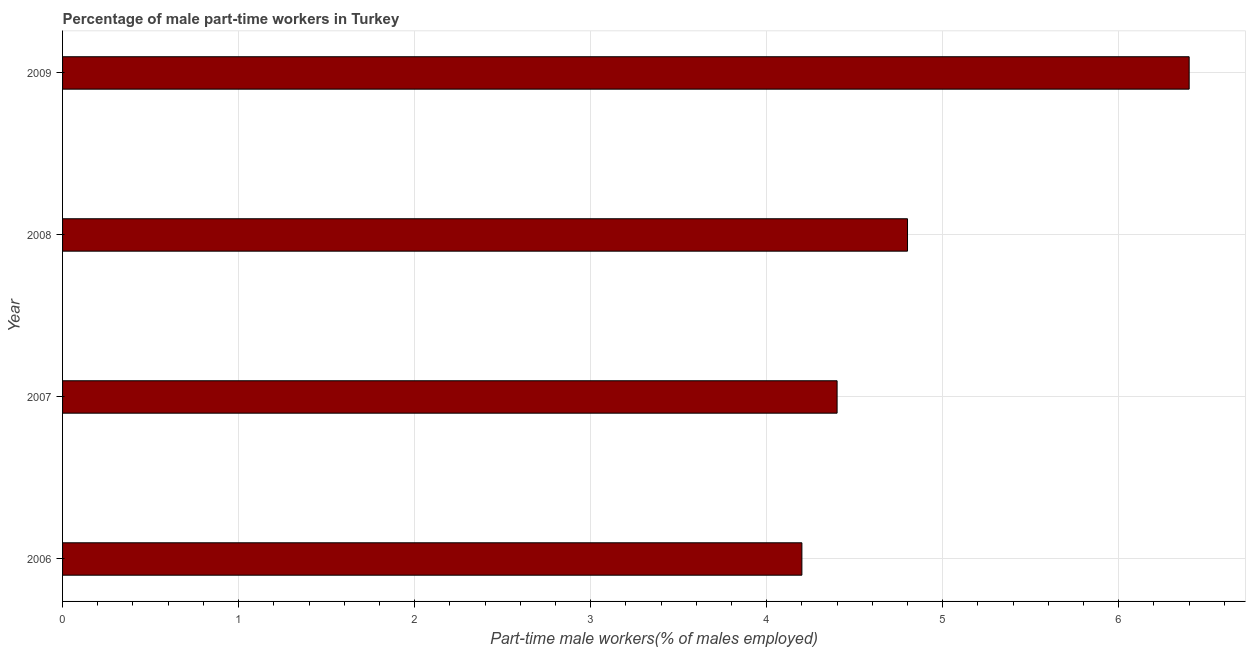Does the graph contain any zero values?
Your answer should be very brief. No. Does the graph contain grids?
Keep it short and to the point. Yes. What is the title of the graph?
Your answer should be compact. Percentage of male part-time workers in Turkey. What is the label or title of the X-axis?
Your response must be concise. Part-time male workers(% of males employed). What is the percentage of part-time male workers in 2009?
Offer a very short reply. 6.4. Across all years, what is the maximum percentage of part-time male workers?
Offer a terse response. 6.4. Across all years, what is the minimum percentage of part-time male workers?
Your answer should be very brief. 4.2. In which year was the percentage of part-time male workers maximum?
Keep it short and to the point. 2009. In which year was the percentage of part-time male workers minimum?
Your answer should be compact. 2006. What is the sum of the percentage of part-time male workers?
Provide a succinct answer. 19.8. What is the average percentage of part-time male workers per year?
Offer a terse response. 4.95. What is the median percentage of part-time male workers?
Offer a very short reply. 4.6. Do a majority of the years between 2008 and 2009 (inclusive) have percentage of part-time male workers greater than 4.8 %?
Give a very brief answer. Yes. What is the ratio of the percentage of part-time male workers in 2006 to that in 2007?
Your answer should be very brief. 0.95. Is the difference between the percentage of part-time male workers in 2006 and 2007 greater than the difference between any two years?
Keep it short and to the point. No. What is the difference between the highest and the second highest percentage of part-time male workers?
Your response must be concise. 1.6. Is the sum of the percentage of part-time male workers in 2006 and 2008 greater than the maximum percentage of part-time male workers across all years?
Ensure brevity in your answer.  Yes. What is the difference between the highest and the lowest percentage of part-time male workers?
Your answer should be very brief. 2.2. In how many years, is the percentage of part-time male workers greater than the average percentage of part-time male workers taken over all years?
Provide a succinct answer. 1. How many bars are there?
Provide a succinct answer. 4. Are all the bars in the graph horizontal?
Make the answer very short. Yes. How many years are there in the graph?
Provide a short and direct response. 4. What is the difference between two consecutive major ticks on the X-axis?
Make the answer very short. 1. What is the Part-time male workers(% of males employed) of 2006?
Your response must be concise. 4.2. What is the Part-time male workers(% of males employed) in 2007?
Your answer should be very brief. 4.4. What is the Part-time male workers(% of males employed) of 2008?
Ensure brevity in your answer.  4.8. What is the Part-time male workers(% of males employed) of 2009?
Offer a terse response. 6.4. What is the difference between the Part-time male workers(% of males employed) in 2006 and 2007?
Your answer should be very brief. -0.2. What is the difference between the Part-time male workers(% of males employed) in 2006 and 2009?
Ensure brevity in your answer.  -2.2. What is the difference between the Part-time male workers(% of males employed) in 2007 and 2008?
Offer a terse response. -0.4. What is the difference between the Part-time male workers(% of males employed) in 2007 and 2009?
Your answer should be very brief. -2. What is the ratio of the Part-time male workers(% of males employed) in 2006 to that in 2007?
Offer a very short reply. 0.95. What is the ratio of the Part-time male workers(% of males employed) in 2006 to that in 2008?
Ensure brevity in your answer.  0.88. What is the ratio of the Part-time male workers(% of males employed) in 2006 to that in 2009?
Your answer should be very brief. 0.66. What is the ratio of the Part-time male workers(% of males employed) in 2007 to that in 2008?
Offer a terse response. 0.92. What is the ratio of the Part-time male workers(% of males employed) in 2007 to that in 2009?
Provide a short and direct response. 0.69. What is the ratio of the Part-time male workers(% of males employed) in 2008 to that in 2009?
Provide a succinct answer. 0.75. 